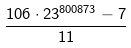<formula> <loc_0><loc_0><loc_500><loc_500>\frac { 1 0 6 \cdot 2 3 ^ { 8 0 0 8 7 3 } - 7 } { 1 1 }</formula> 